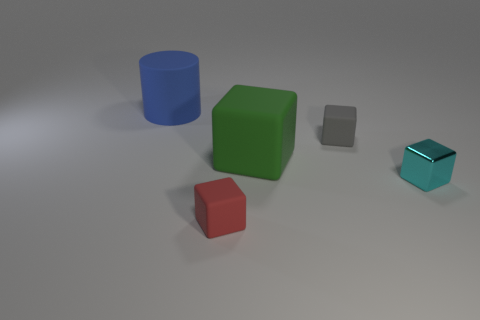There is a shiny block; is it the same size as the object on the left side of the red rubber block?
Provide a succinct answer. No. What size is the gray object that is the same shape as the cyan metallic object?
Ensure brevity in your answer.  Small. Is there any other thing that is the same material as the cyan thing?
Your response must be concise. No. Do the rubber cylinder behind the shiny object and the green matte object on the left side of the tiny cyan object have the same size?
Offer a terse response. Yes. What number of tiny objects are either cubes or shiny cubes?
Your answer should be compact. 3. What number of tiny cubes are in front of the big block and right of the big green cube?
Offer a very short reply. 1. Are the large blue object and the small cube to the right of the small gray matte cube made of the same material?
Your answer should be very brief. No. How many cyan objects are either big blocks or metal cubes?
Provide a short and direct response. 1. Are there any objects of the same size as the metallic cube?
Offer a terse response. Yes. The cube that is on the right side of the tiny matte thing that is behind the matte object that is in front of the big green rubber cube is made of what material?
Offer a very short reply. Metal. 